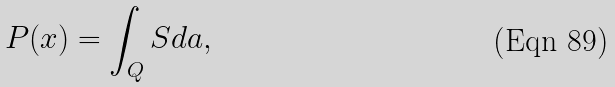<formula> <loc_0><loc_0><loc_500><loc_500>P ( x ) = \int _ { Q } S d a ,</formula> 